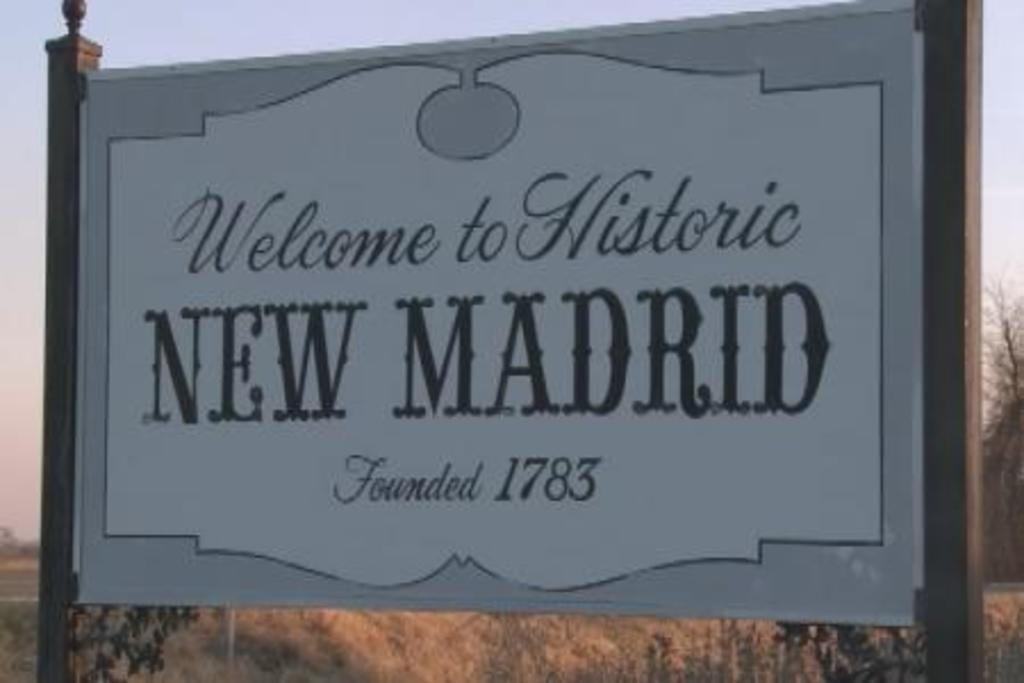<image>
Describe the image concisely. Billboard that is welcoming you to New Madrid. 